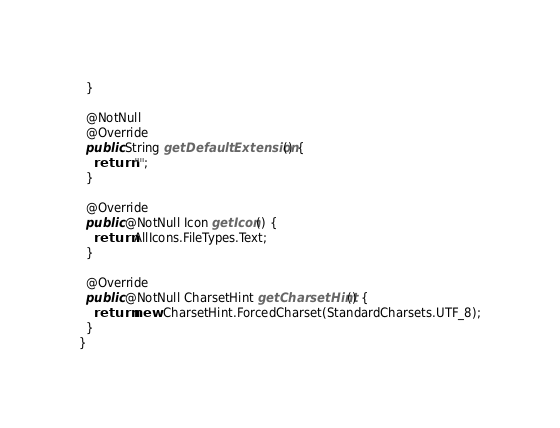Convert code to text. <code><loc_0><loc_0><loc_500><loc_500><_Java_>  }

  @NotNull
  @Override
  public String getDefaultExtension() {
    return "";
  }

  @Override
  public @NotNull Icon getIcon() {
    return AllIcons.FileTypes.Text;
  }

  @Override
  public @NotNull CharsetHint getCharsetHint() {
    return new CharsetHint.ForcedCharset(StandardCharsets.UTF_8);
  }
}
</code> 